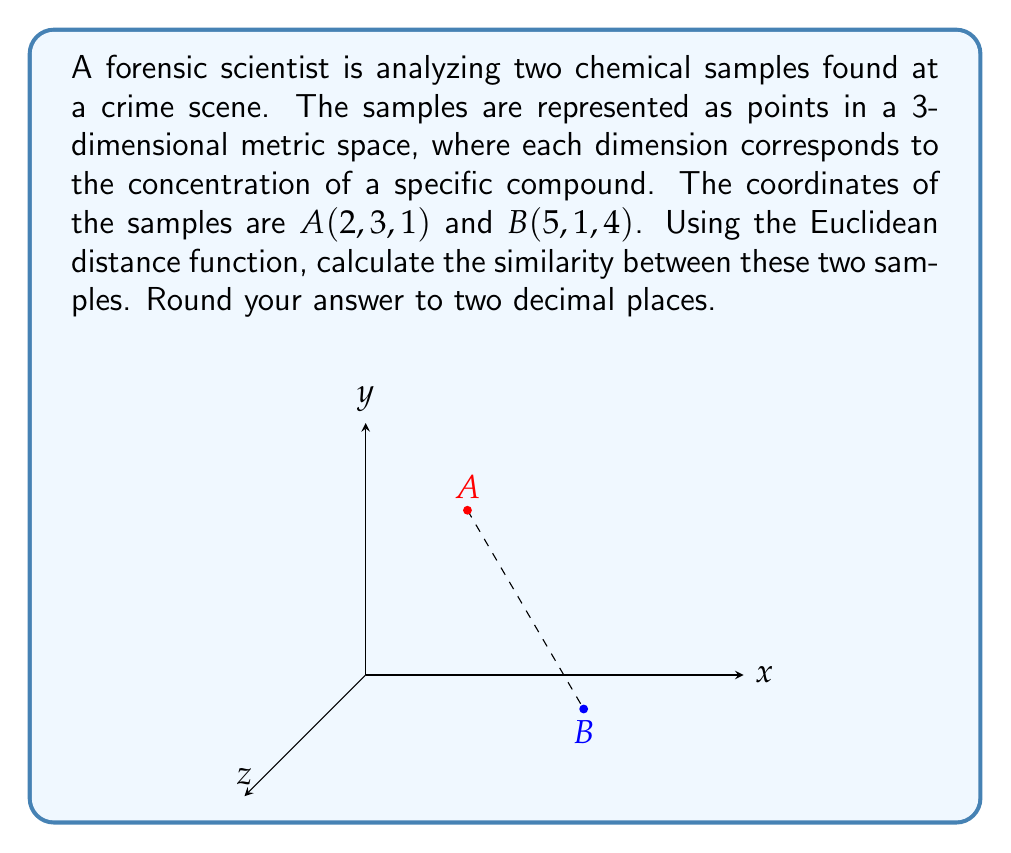Show me your answer to this math problem. To evaluate the similarity between the two chemical samples using the Euclidean distance function in a 3-dimensional metric space, we follow these steps:

1) The Euclidean distance function for two points $P_1(x_1, y_1, z_1)$ and $P_2(x_2, y_2, z_2)$ in 3D space is given by:

   $$d(P_1, P_2) = \sqrt{(x_2-x_1)^2 + (y_2-y_1)^2 + (z_2-z_1)^2}$$

2) In this case, we have:
   $A(2, 3, 1)$ and $B(5, 1, 4)$

3) Let's substitute these values into the formula:

   $$d(A, B) = \sqrt{(5-2)^2 + (1-3)^2 + (4-1)^2}$$

4) Simplify:
   $$d(A, B) = \sqrt{3^2 + (-2)^2 + 3^2}$$

5) Calculate:
   $$d(A, B) = \sqrt{9 + 4 + 9} = \sqrt{22}$$

6) Evaluate and round to two decimal places:
   $$d(A, B) \approx 4.69$$

The Euclidean distance between the two samples is approximately 4.69 units. In the context of chemical similarity, a smaller distance indicates greater similarity. Therefore, this value represents the degree of dissimilarity between the samples.
Answer: 4.69 